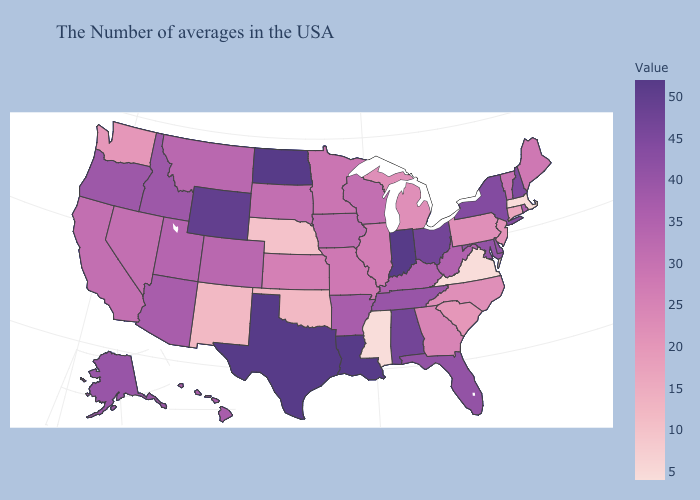Which states hav the highest value in the West?
Be succinct. Wyoming. Does Alaska have the lowest value in the West?
Short answer required. No. Among the states that border Mississippi , which have the lowest value?
Short answer required. Arkansas. Does Texas have the highest value in the USA?
Answer briefly. Yes. Among the states that border Oregon , does California have the highest value?
Quick response, please. No. Among the states that border Arkansas , does Texas have the highest value?
Answer briefly. Yes. Which states have the highest value in the USA?
Answer briefly. Indiana, Louisiana, Texas, North Dakota. Which states hav the highest value in the West?
Quick response, please. Wyoming. 